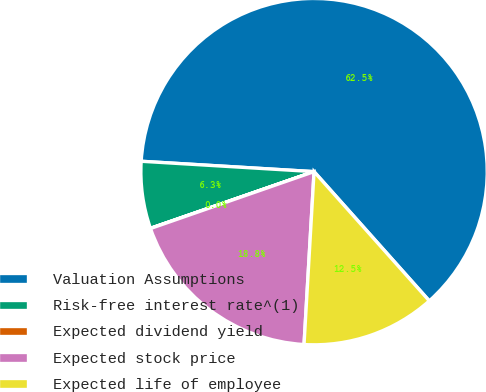<chart> <loc_0><loc_0><loc_500><loc_500><pie_chart><fcel>Valuation Assumptions<fcel>Risk-free interest rate^(1)<fcel>Expected dividend yield<fcel>Expected stock price<fcel>Expected life of employee<nl><fcel>62.45%<fcel>6.26%<fcel>0.02%<fcel>18.75%<fcel>12.51%<nl></chart> 